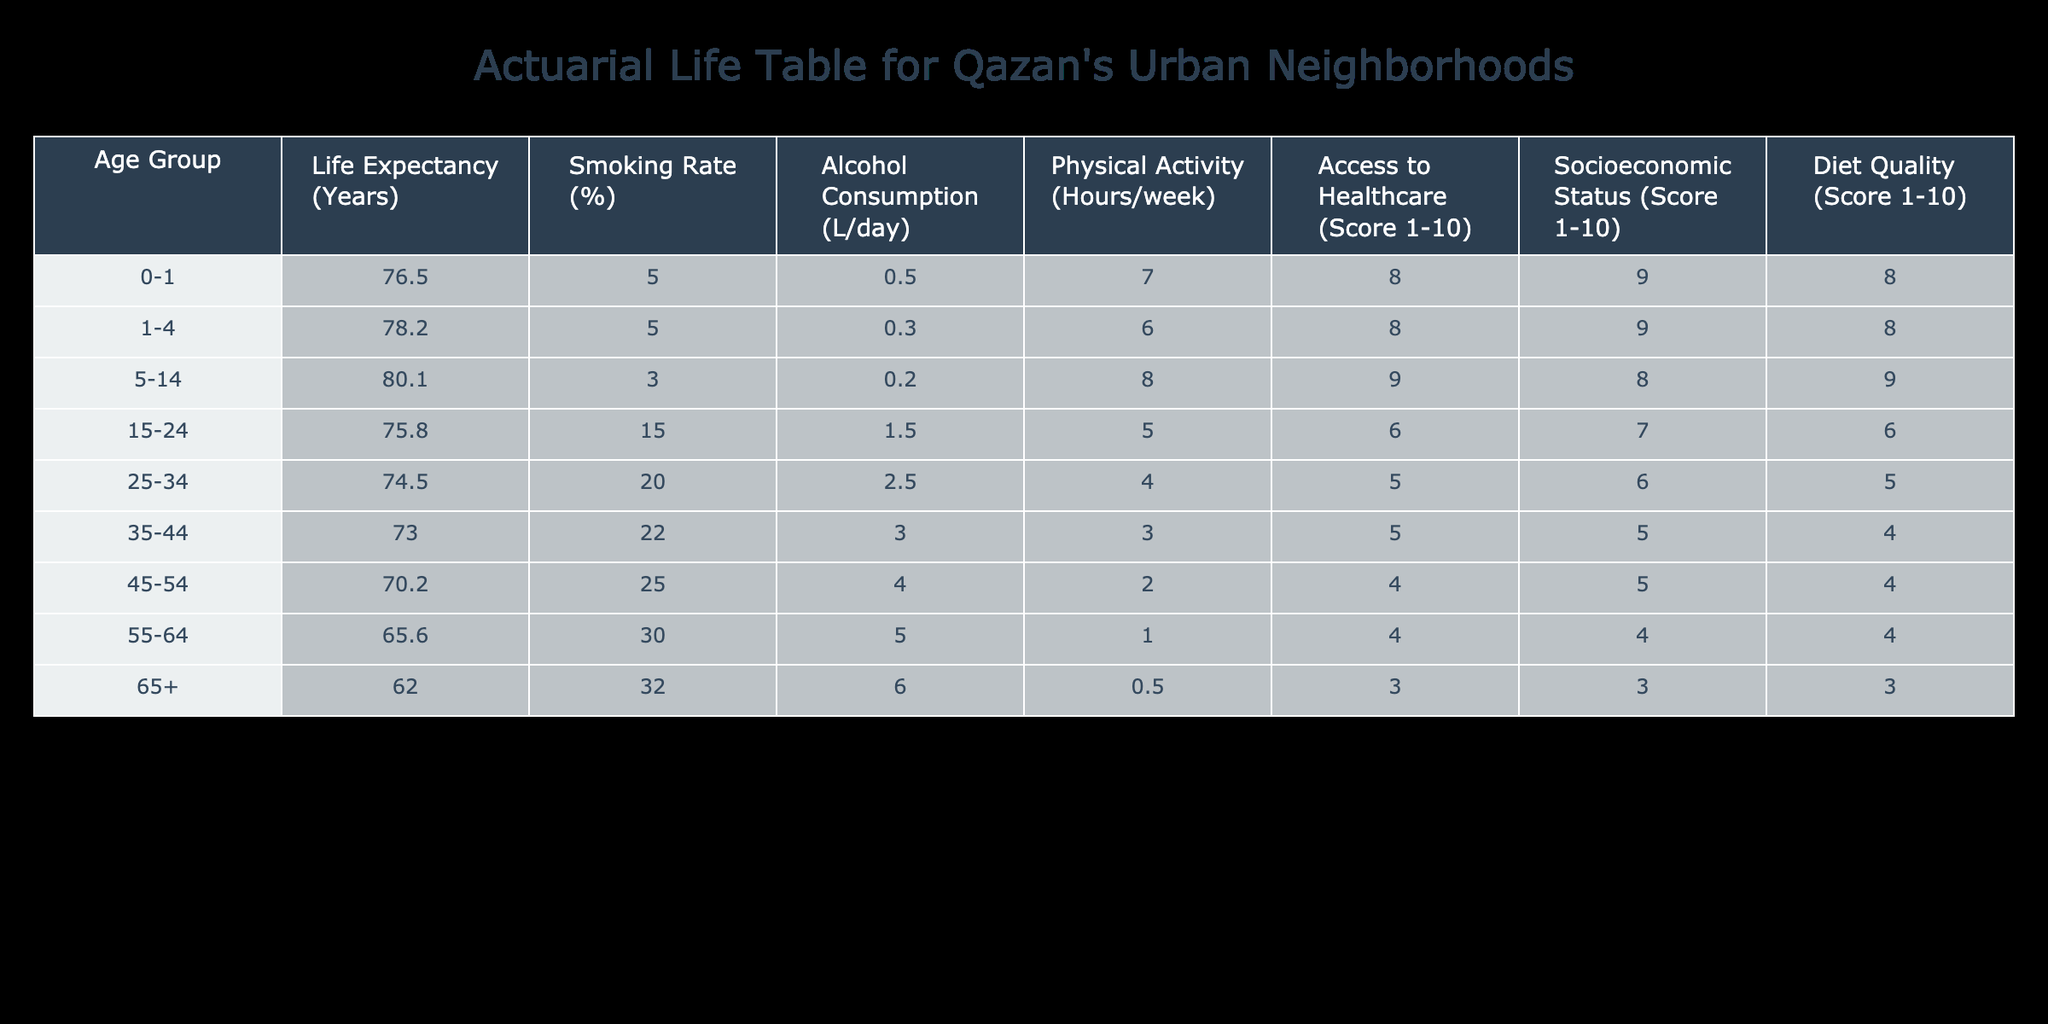What is the life expectancy for the age group 25-34? The table shows that the life expectancy for the age group 25-34 is listed directly under the appropriate column. Therefore, I can find that the life expectancy is 74.5 years.
Answer: 74.5 What is the smoking rate for the age group 45-54? By referring to the table, I can see that the smoking rate for the age group 45-54 is also clearly stated in the corresponding column, which is 25%.
Answer: 25% What is the average access to healthcare score for all age groups? To find the average access to healthcare, I need to sum all the access scores: (8 + 8 + 9 + 6 + 5 + 4 + 4 + 3) = 47. Then, divide by the number of age groups (8): 47 / 8 = 5.875, which can be rounded to 5.9.
Answer: 5.9 Does the life expectancy increase with higher diet quality in Qazan's urban neighborhoods? I need to check the table for the relationship between life expectancy and diet quality. Analyzing the data, the age groups with lower diet quality (e.g., 45-54 with 4 and life expectancy 70.2, and 55-64 with 4 and life expectancy 65.6) show that as diet quality decreases, life expectancy also tends to decrease. Hence, it can be inferred that there is a negative correlation in this case.
Answer: Yes What is the difference in life expectancy between the age groups 0-1 and 65+? The life expectancy for the age group 0-1 is 76.5 years, and for 65+, it is 62.0 years. The difference is 76.5 - 62.0 = 14.5 years.
Answer: 14.5 Is the average alcohol consumption higher for the age group 15-24 compared to the age group 35-44? The table lists alcohol consumption for age group 15-24 at 1.5 L/day and for 35-44 at 3.0 L/day. Since 1.5 is less than 3.0, the average alcohol consumption is not higher for 15-24.
Answer: No Which age group has the highest socioeconomic status score? Reviewing the table, the highest socioeconomic status score is found in the 0-1 age group with a score of 9.
Answer: 0-1 What is the trend in physical activity hours as age increases? Checking the physical activity hours across age groups, the figures are as follows: 7, 6, 8, 5, 4, 3, 2, 1. I can see that the hours of physical activity decrease as the age increases.
Answer: Decrease 